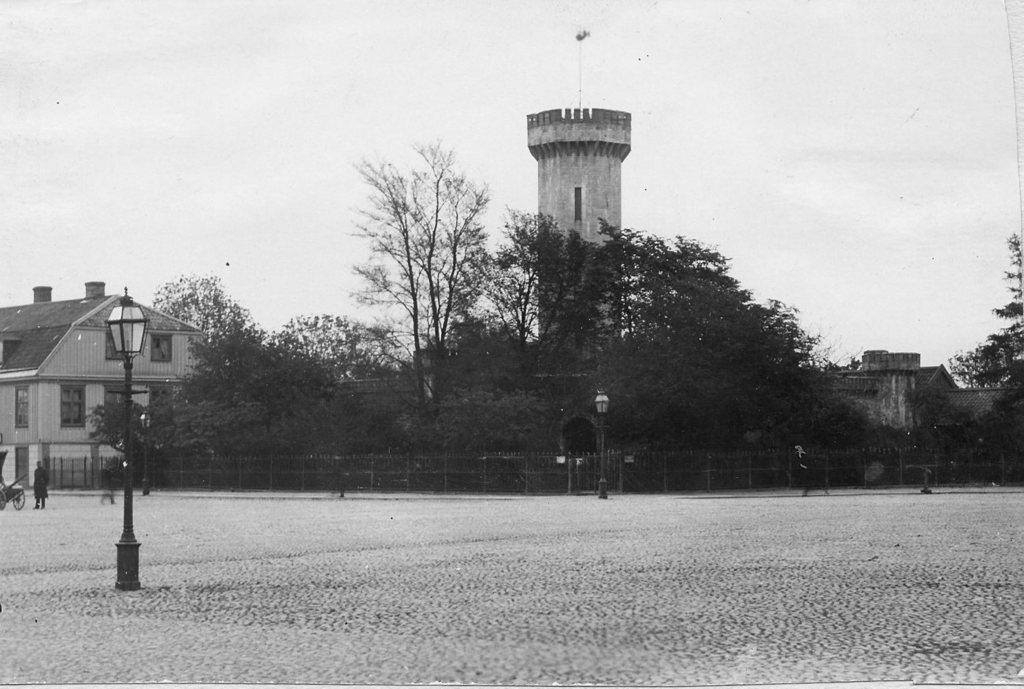Where was the image taken? The image was taken on a road. What can be seen at the bottom of the image? There is a road at the bottom of the image. What structure is located to the left of the image? There is a house to the left of the image. What type of vegetation is visible in the background of the image? There are trees in the background of the image. What is visible at the top of the image? The sky is visible at the top of the image. How many actors are present in the image? There are no actors present in the image. What type of carriage can be seen in the background of the image? There is no carriage present in the image. 